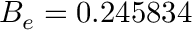<formula> <loc_0><loc_0><loc_500><loc_500>B _ { e } = 0 . 2 4 5 8 3 4</formula> 